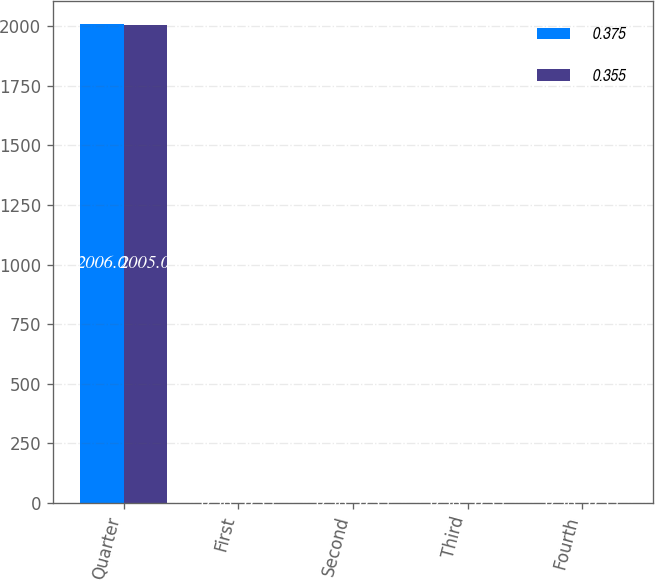Convert chart to OTSL. <chart><loc_0><loc_0><loc_500><loc_500><stacked_bar_chart><ecel><fcel>Quarter<fcel>First<fcel>Second<fcel>Third<fcel>Fourth<nl><fcel>0.375<fcel>2006<fcel>0.38<fcel>0.38<fcel>0.38<fcel>0.38<nl><fcel>0.355<fcel>2005<fcel>0.35<fcel>0.35<fcel>0.35<fcel>0.35<nl></chart> 